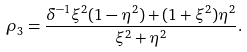Convert formula to latex. <formula><loc_0><loc_0><loc_500><loc_500>\rho _ { 3 } = \frac { \delta ^ { - 1 } \xi ^ { 2 } ( 1 - \eta ^ { 2 } ) + ( 1 + \xi ^ { 2 } ) \eta ^ { 2 } } { \xi ^ { 2 } + \eta ^ { 2 } } .</formula> 